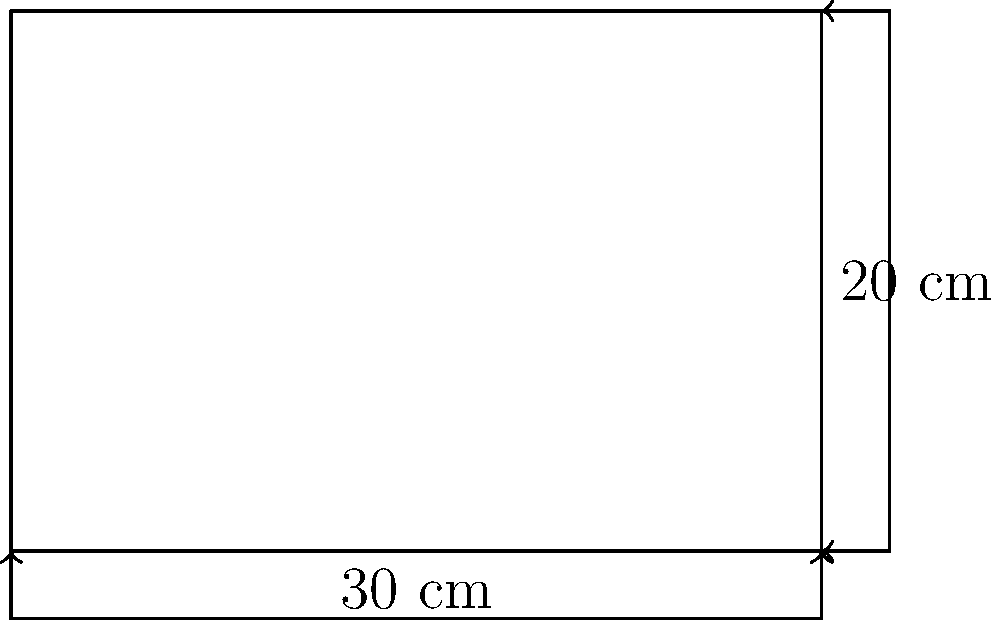You've decided to organize your cloth diaper storage area. You have a rectangular storage bin with a length of 30 cm and a width of 20 cm. What is the area of the base of this storage bin in square centimeters? To find the area of a rectangular storage bin, we need to multiply its length by its width. Let's break it down step-by-step:

1. Identify the given dimensions:
   - Length = 30 cm
   - Width = 20 cm

2. Use the formula for the area of a rectangle:
   $A = l \times w$
   Where:
   $A$ = Area
   $l$ = Length
   $w$ = Width

3. Substitute the values into the formula:
   $A = 30 \text{ cm} \times 20 \text{ cm}$

4. Multiply:
   $A = 600 \text{ cm}^2$

Therefore, the area of the base of the storage bin is 600 square centimeters.
Answer: $600 \text{ cm}^2$ 